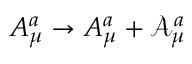<formula> <loc_0><loc_0><loc_500><loc_500>A _ { \mu } ^ { a } \rightarrow A _ { \mu } ^ { a } + \mathcal { A } _ { \mu } ^ { a }</formula> 